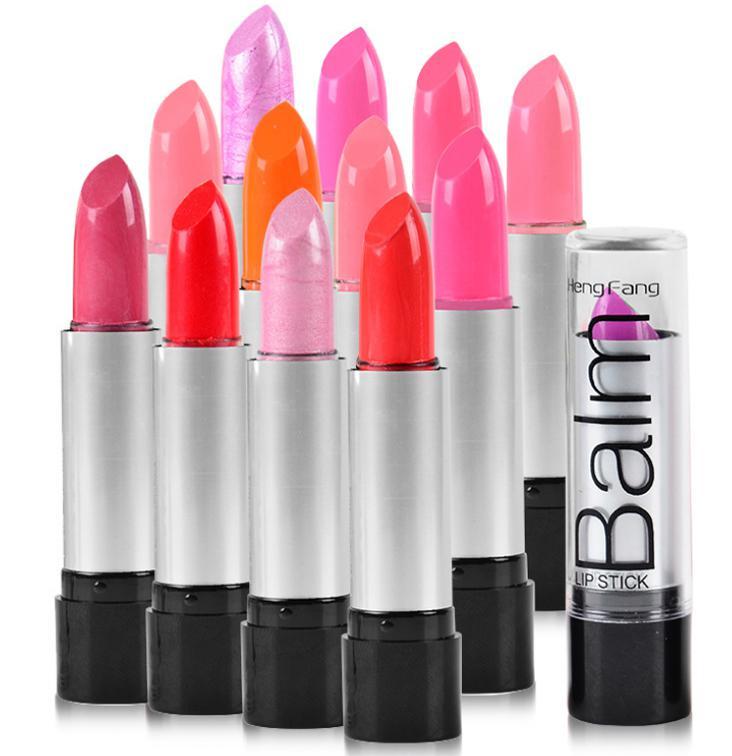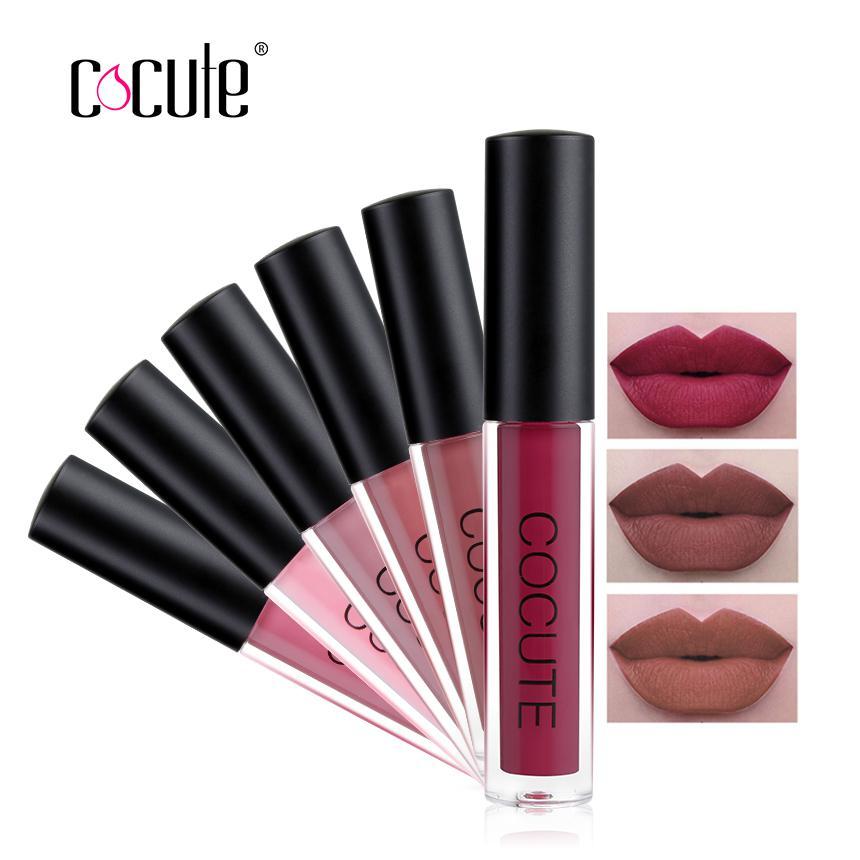The first image is the image on the left, the second image is the image on the right. Analyze the images presented: Is the assertion "Exactly two lipsticks are shown, one of them capped, but with a lip photo display, while the other is open with the lipstick extended." valid? Answer yes or no. No. The first image is the image on the left, the second image is the image on the right. For the images shown, is this caption "An image shows one pair of painted lips to the right of a single lip makeup product." true? Answer yes or no. No. 